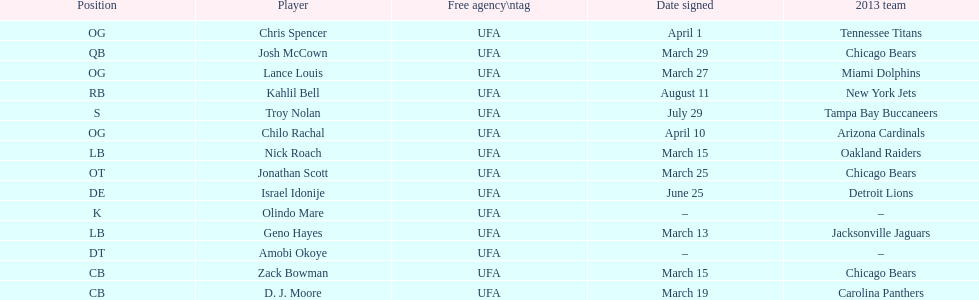Who was the previous player signed before troy nolan? Israel Idonije. 